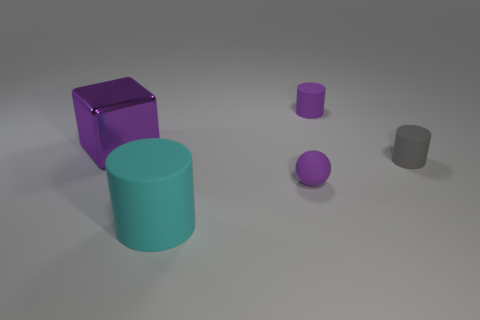Subtract all tiny rubber cylinders. How many cylinders are left? 1 Add 2 small gray matte cylinders. How many objects exist? 7 Subtract all blocks. How many objects are left? 4 Subtract all purple things. Subtract all big yellow cylinders. How many objects are left? 2 Add 1 tiny purple cylinders. How many tiny purple cylinders are left? 2 Add 3 cubes. How many cubes exist? 4 Subtract 0 yellow cylinders. How many objects are left? 5 